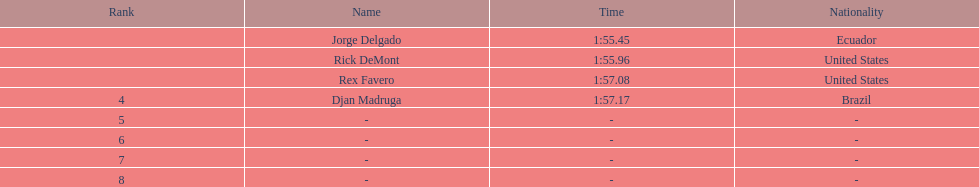What is the time for each name 1:55.45, 1:55.96, 1:57.08, 1:57.17. 